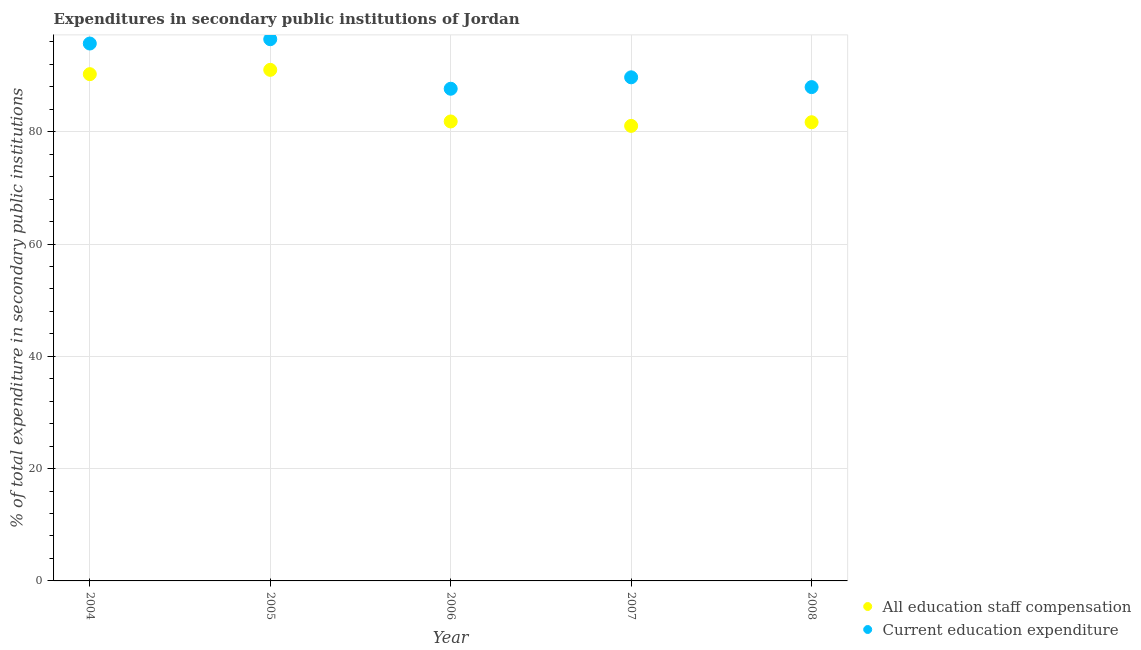How many different coloured dotlines are there?
Keep it short and to the point. 2. What is the expenditure in education in 2007?
Provide a short and direct response. 89.68. Across all years, what is the maximum expenditure in staff compensation?
Ensure brevity in your answer.  91.01. Across all years, what is the minimum expenditure in staff compensation?
Provide a short and direct response. 81.03. What is the total expenditure in staff compensation in the graph?
Keep it short and to the point. 425.8. What is the difference between the expenditure in staff compensation in 2004 and that in 2005?
Offer a terse response. -0.77. What is the difference between the expenditure in education in 2005 and the expenditure in staff compensation in 2004?
Ensure brevity in your answer.  6.22. What is the average expenditure in education per year?
Provide a short and direct response. 91.49. In the year 2006, what is the difference between the expenditure in staff compensation and expenditure in education?
Offer a terse response. -5.83. In how many years, is the expenditure in staff compensation greater than 44 %?
Your answer should be very brief. 5. What is the ratio of the expenditure in education in 2004 to that in 2005?
Make the answer very short. 0.99. Is the difference between the expenditure in education in 2004 and 2005 greater than the difference between the expenditure in staff compensation in 2004 and 2005?
Give a very brief answer. No. What is the difference between the highest and the second highest expenditure in staff compensation?
Your answer should be compact. 0.77. What is the difference between the highest and the lowest expenditure in staff compensation?
Provide a succinct answer. 9.98. Is the expenditure in education strictly greater than the expenditure in staff compensation over the years?
Offer a terse response. Yes. How many dotlines are there?
Provide a short and direct response. 2. What is the difference between two consecutive major ticks on the Y-axis?
Ensure brevity in your answer.  20. Are the values on the major ticks of Y-axis written in scientific E-notation?
Make the answer very short. No. Does the graph contain any zero values?
Offer a very short reply. No. Does the graph contain grids?
Your answer should be very brief. Yes. How many legend labels are there?
Offer a very short reply. 2. How are the legend labels stacked?
Ensure brevity in your answer.  Vertical. What is the title of the graph?
Ensure brevity in your answer.  Expenditures in secondary public institutions of Jordan. What is the label or title of the Y-axis?
Keep it short and to the point. % of total expenditure in secondary public institutions. What is the % of total expenditure in secondary public institutions of All education staff compensation in 2004?
Your answer should be compact. 90.25. What is the % of total expenditure in secondary public institutions in Current education expenditure in 2004?
Your response must be concise. 95.7. What is the % of total expenditure in secondary public institutions in All education staff compensation in 2005?
Ensure brevity in your answer.  91.01. What is the % of total expenditure in secondary public institutions in Current education expenditure in 2005?
Your answer should be very brief. 96.47. What is the % of total expenditure in secondary public institutions of All education staff compensation in 2006?
Your response must be concise. 81.82. What is the % of total expenditure in secondary public institutions in Current education expenditure in 2006?
Offer a very short reply. 87.65. What is the % of total expenditure in secondary public institutions of All education staff compensation in 2007?
Offer a terse response. 81.03. What is the % of total expenditure in secondary public institutions in Current education expenditure in 2007?
Keep it short and to the point. 89.68. What is the % of total expenditure in secondary public institutions in All education staff compensation in 2008?
Your answer should be very brief. 81.69. What is the % of total expenditure in secondary public institutions of Current education expenditure in 2008?
Offer a terse response. 87.94. Across all years, what is the maximum % of total expenditure in secondary public institutions in All education staff compensation?
Your answer should be very brief. 91.01. Across all years, what is the maximum % of total expenditure in secondary public institutions of Current education expenditure?
Make the answer very short. 96.47. Across all years, what is the minimum % of total expenditure in secondary public institutions in All education staff compensation?
Provide a succinct answer. 81.03. Across all years, what is the minimum % of total expenditure in secondary public institutions of Current education expenditure?
Offer a terse response. 87.65. What is the total % of total expenditure in secondary public institutions of All education staff compensation in the graph?
Offer a very short reply. 425.8. What is the total % of total expenditure in secondary public institutions of Current education expenditure in the graph?
Your answer should be very brief. 457.44. What is the difference between the % of total expenditure in secondary public institutions in All education staff compensation in 2004 and that in 2005?
Your response must be concise. -0.77. What is the difference between the % of total expenditure in secondary public institutions in Current education expenditure in 2004 and that in 2005?
Give a very brief answer. -0.77. What is the difference between the % of total expenditure in secondary public institutions in All education staff compensation in 2004 and that in 2006?
Ensure brevity in your answer.  8.42. What is the difference between the % of total expenditure in secondary public institutions of Current education expenditure in 2004 and that in 2006?
Your answer should be very brief. 8.05. What is the difference between the % of total expenditure in secondary public institutions of All education staff compensation in 2004 and that in 2007?
Your answer should be very brief. 9.21. What is the difference between the % of total expenditure in secondary public institutions of Current education expenditure in 2004 and that in 2007?
Your answer should be compact. 6.02. What is the difference between the % of total expenditure in secondary public institutions in All education staff compensation in 2004 and that in 2008?
Provide a short and direct response. 8.56. What is the difference between the % of total expenditure in secondary public institutions of Current education expenditure in 2004 and that in 2008?
Give a very brief answer. 7.76. What is the difference between the % of total expenditure in secondary public institutions of All education staff compensation in 2005 and that in 2006?
Offer a very short reply. 9.19. What is the difference between the % of total expenditure in secondary public institutions of Current education expenditure in 2005 and that in 2006?
Make the answer very short. 8.82. What is the difference between the % of total expenditure in secondary public institutions in All education staff compensation in 2005 and that in 2007?
Give a very brief answer. 9.98. What is the difference between the % of total expenditure in secondary public institutions of Current education expenditure in 2005 and that in 2007?
Your response must be concise. 6.79. What is the difference between the % of total expenditure in secondary public institutions of All education staff compensation in 2005 and that in 2008?
Ensure brevity in your answer.  9.33. What is the difference between the % of total expenditure in secondary public institutions in Current education expenditure in 2005 and that in 2008?
Offer a very short reply. 8.53. What is the difference between the % of total expenditure in secondary public institutions of All education staff compensation in 2006 and that in 2007?
Keep it short and to the point. 0.79. What is the difference between the % of total expenditure in secondary public institutions in Current education expenditure in 2006 and that in 2007?
Your answer should be very brief. -2.03. What is the difference between the % of total expenditure in secondary public institutions of All education staff compensation in 2006 and that in 2008?
Make the answer very short. 0.14. What is the difference between the % of total expenditure in secondary public institutions in Current education expenditure in 2006 and that in 2008?
Offer a terse response. -0.29. What is the difference between the % of total expenditure in secondary public institutions of All education staff compensation in 2007 and that in 2008?
Provide a short and direct response. -0.65. What is the difference between the % of total expenditure in secondary public institutions of Current education expenditure in 2007 and that in 2008?
Provide a short and direct response. 1.74. What is the difference between the % of total expenditure in secondary public institutions of All education staff compensation in 2004 and the % of total expenditure in secondary public institutions of Current education expenditure in 2005?
Your answer should be very brief. -6.22. What is the difference between the % of total expenditure in secondary public institutions of All education staff compensation in 2004 and the % of total expenditure in secondary public institutions of Current education expenditure in 2006?
Offer a terse response. 2.6. What is the difference between the % of total expenditure in secondary public institutions in All education staff compensation in 2004 and the % of total expenditure in secondary public institutions in Current education expenditure in 2007?
Give a very brief answer. 0.56. What is the difference between the % of total expenditure in secondary public institutions of All education staff compensation in 2004 and the % of total expenditure in secondary public institutions of Current education expenditure in 2008?
Offer a terse response. 2.31. What is the difference between the % of total expenditure in secondary public institutions of All education staff compensation in 2005 and the % of total expenditure in secondary public institutions of Current education expenditure in 2006?
Your answer should be very brief. 3.36. What is the difference between the % of total expenditure in secondary public institutions in All education staff compensation in 2005 and the % of total expenditure in secondary public institutions in Current education expenditure in 2007?
Provide a short and direct response. 1.33. What is the difference between the % of total expenditure in secondary public institutions of All education staff compensation in 2005 and the % of total expenditure in secondary public institutions of Current education expenditure in 2008?
Offer a very short reply. 3.07. What is the difference between the % of total expenditure in secondary public institutions of All education staff compensation in 2006 and the % of total expenditure in secondary public institutions of Current education expenditure in 2007?
Give a very brief answer. -7.86. What is the difference between the % of total expenditure in secondary public institutions in All education staff compensation in 2006 and the % of total expenditure in secondary public institutions in Current education expenditure in 2008?
Your answer should be very brief. -6.12. What is the difference between the % of total expenditure in secondary public institutions of All education staff compensation in 2007 and the % of total expenditure in secondary public institutions of Current education expenditure in 2008?
Offer a terse response. -6.9. What is the average % of total expenditure in secondary public institutions of All education staff compensation per year?
Your response must be concise. 85.16. What is the average % of total expenditure in secondary public institutions in Current education expenditure per year?
Your answer should be compact. 91.49. In the year 2004, what is the difference between the % of total expenditure in secondary public institutions in All education staff compensation and % of total expenditure in secondary public institutions in Current education expenditure?
Ensure brevity in your answer.  -5.45. In the year 2005, what is the difference between the % of total expenditure in secondary public institutions of All education staff compensation and % of total expenditure in secondary public institutions of Current education expenditure?
Keep it short and to the point. -5.46. In the year 2006, what is the difference between the % of total expenditure in secondary public institutions in All education staff compensation and % of total expenditure in secondary public institutions in Current education expenditure?
Give a very brief answer. -5.83. In the year 2007, what is the difference between the % of total expenditure in secondary public institutions of All education staff compensation and % of total expenditure in secondary public institutions of Current education expenditure?
Provide a short and direct response. -8.65. In the year 2008, what is the difference between the % of total expenditure in secondary public institutions of All education staff compensation and % of total expenditure in secondary public institutions of Current education expenditure?
Offer a very short reply. -6.25. What is the ratio of the % of total expenditure in secondary public institutions in All education staff compensation in 2004 to that in 2006?
Offer a very short reply. 1.1. What is the ratio of the % of total expenditure in secondary public institutions in Current education expenditure in 2004 to that in 2006?
Give a very brief answer. 1.09. What is the ratio of the % of total expenditure in secondary public institutions of All education staff compensation in 2004 to that in 2007?
Your response must be concise. 1.11. What is the ratio of the % of total expenditure in secondary public institutions of Current education expenditure in 2004 to that in 2007?
Your answer should be very brief. 1.07. What is the ratio of the % of total expenditure in secondary public institutions in All education staff compensation in 2004 to that in 2008?
Keep it short and to the point. 1.1. What is the ratio of the % of total expenditure in secondary public institutions in Current education expenditure in 2004 to that in 2008?
Your answer should be compact. 1.09. What is the ratio of the % of total expenditure in secondary public institutions in All education staff compensation in 2005 to that in 2006?
Ensure brevity in your answer.  1.11. What is the ratio of the % of total expenditure in secondary public institutions of Current education expenditure in 2005 to that in 2006?
Provide a succinct answer. 1.1. What is the ratio of the % of total expenditure in secondary public institutions in All education staff compensation in 2005 to that in 2007?
Your answer should be very brief. 1.12. What is the ratio of the % of total expenditure in secondary public institutions of Current education expenditure in 2005 to that in 2007?
Provide a succinct answer. 1.08. What is the ratio of the % of total expenditure in secondary public institutions of All education staff compensation in 2005 to that in 2008?
Make the answer very short. 1.11. What is the ratio of the % of total expenditure in secondary public institutions in Current education expenditure in 2005 to that in 2008?
Your response must be concise. 1.1. What is the ratio of the % of total expenditure in secondary public institutions in All education staff compensation in 2006 to that in 2007?
Keep it short and to the point. 1.01. What is the ratio of the % of total expenditure in secondary public institutions in Current education expenditure in 2006 to that in 2007?
Your response must be concise. 0.98. What is the ratio of the % of total expenditure in secondary public institutions of All education staff compensation in 2006 to that in 2008?
Offer a very short reply. 1. What is the ratio of the % of total expenditure in secondary public institutions in Current education expenditure in 2006 to that in 2008?
Keep it short and to the point. 1. What is the ratio of the % of total expenditure in secondary public institutions in All education staff compensation in 2007 to that in 2008?
Offer a very short reply. 0.99. What is the ratio of the % of total expenditure in secondary public institutions of Current education expenditure in 2007 to that in 2008?
Provide a succinct answer. 1.02. What is the difference between the highest and the second highest % of total expenditure in secondary public institutions of All education staff compensation?
Give a very brief answer. 0.77. What is the difference between the highest and the second highest % of total expenditure in secondary public institutions in Current education expenditure?
Give a very brief answer. 0.77. What is the difference between the highest and the lowest % of total expenditure in secondary public institutions of All education staff compensation?
Provide a short and direct response. 9.98. What is the difference between the highest and the lowest % of total expenditure in secondary public institutions in Current education expenditure?
Ensure brevity in your answer.  8.82. 